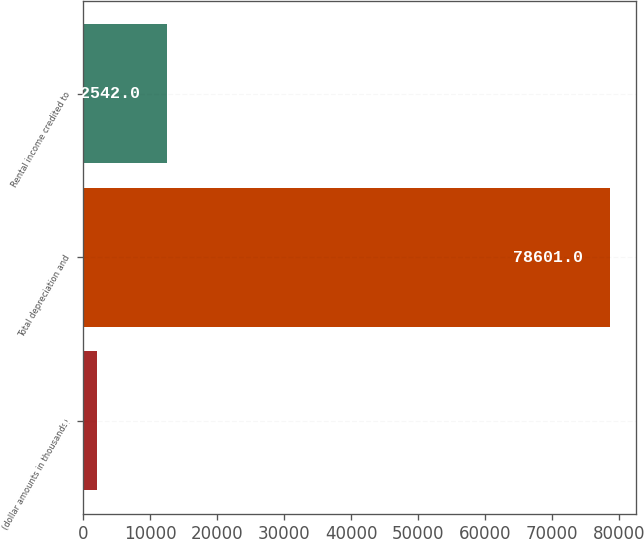<chart> <loc_0><loc_0><loc_500><loc_500><bar_chart><fcel>(dollar amounts in thousands)<fcel>Total depreciation and<fcel>Rental income credited to<nl><fcel>2013<fcel>78601<fcel>12542<nl></chart> 